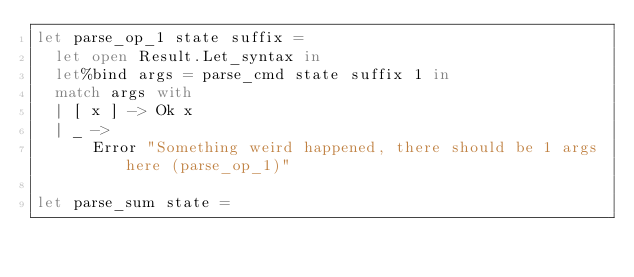Convert code to text. <code><loc_0><loc_0><loc_500><loc_500><_OCaml_>let parse_op_1 state suffix =
  let open Result.Let_syntax in
  let%bind args = parse_cmd state suffix 1 in
  match args with
  | [ x ] -> Ok x
  | _ ->
      Error "Something weird happened, there should be 1 args here (parse_op_1)"

let parse_sum state =</code> 